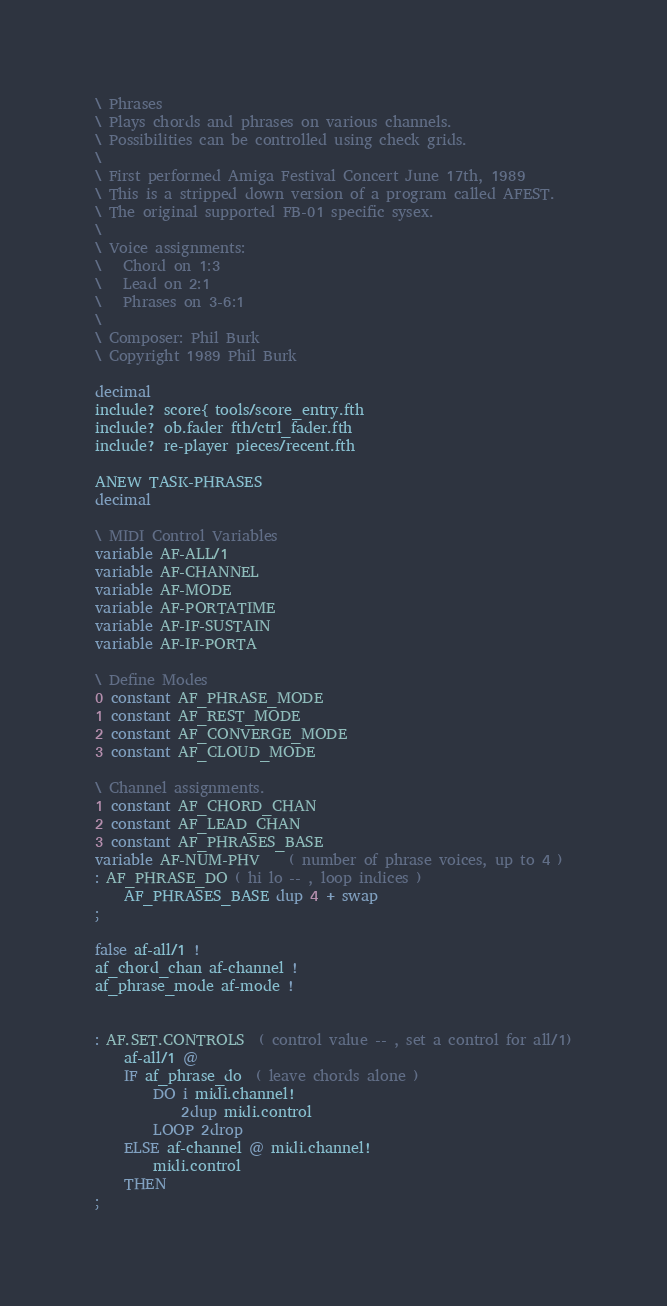<code> <loc_0><loc_0><loc_500><loc_500><_Forth_>\ Phrases
\ Plays chords and phrases on various channels.
\ Possibilities can be controlled using check grids.
\
\ First performed Amiga Festival Concert June 17th, 1989
\ This is a stripped down version of a program called AFEST.
\ The original supported FB-01 specific sysex.
\
\ Voice assignments:
\   Chord on 1:3
\   Lead on 2:1
\   Phrases on 3-6:1
\
\ Composer: Phil Burk
\ Copyright 1989 Phil Burk

decimal
include? score{ tools/score_entry.fth
include? ob.fader fth/ctrl_fader.fth
include? re-player pieces/recent.fth

ANEW TASK-PHRASES
decimal

\ MIDI Control Variables
variable AF-ALL/1
variable AF-CHANNEL
variable AF-MODE
variable AF-PORTATIME
variable AF-IF-SUSTAIN
variable AF-IF-PORTA

\ Define Modes
0 constant AF_PHRASE_MODE
1 constant AF_REST_MODE
2 constant AF_CONVERGE_MODE
3 constant AF_CLOUD_MODE

\ Channel assignments.
1 constant AF_CHORD_CHAN
2 constant AF_LEAD_CHAN
3 constant AF_PHRASES_BASE
variable AF-NUM-PHV    ( number of phrase voices, up to 4 )
: AF_PHRASE_DO ( hi lo -- , loop indices )
    AF_PHRASES_BASE dup 4 + swap
;

false af-all/1 !
af_chord_chan af-channel !
af_phrase_mode af-mode !


: AF.SET.CONTROLS  ( control value -- , set a control for all/1)
    af-all/1 @
    IF af_phrase_do  ( leave chords alone )
        DO i midi.channel!
            2dup midi.control
        LOOP 2drop
    ELSE af-channel @ midi.channel!
        midi.control
    THEN
;
</code> 